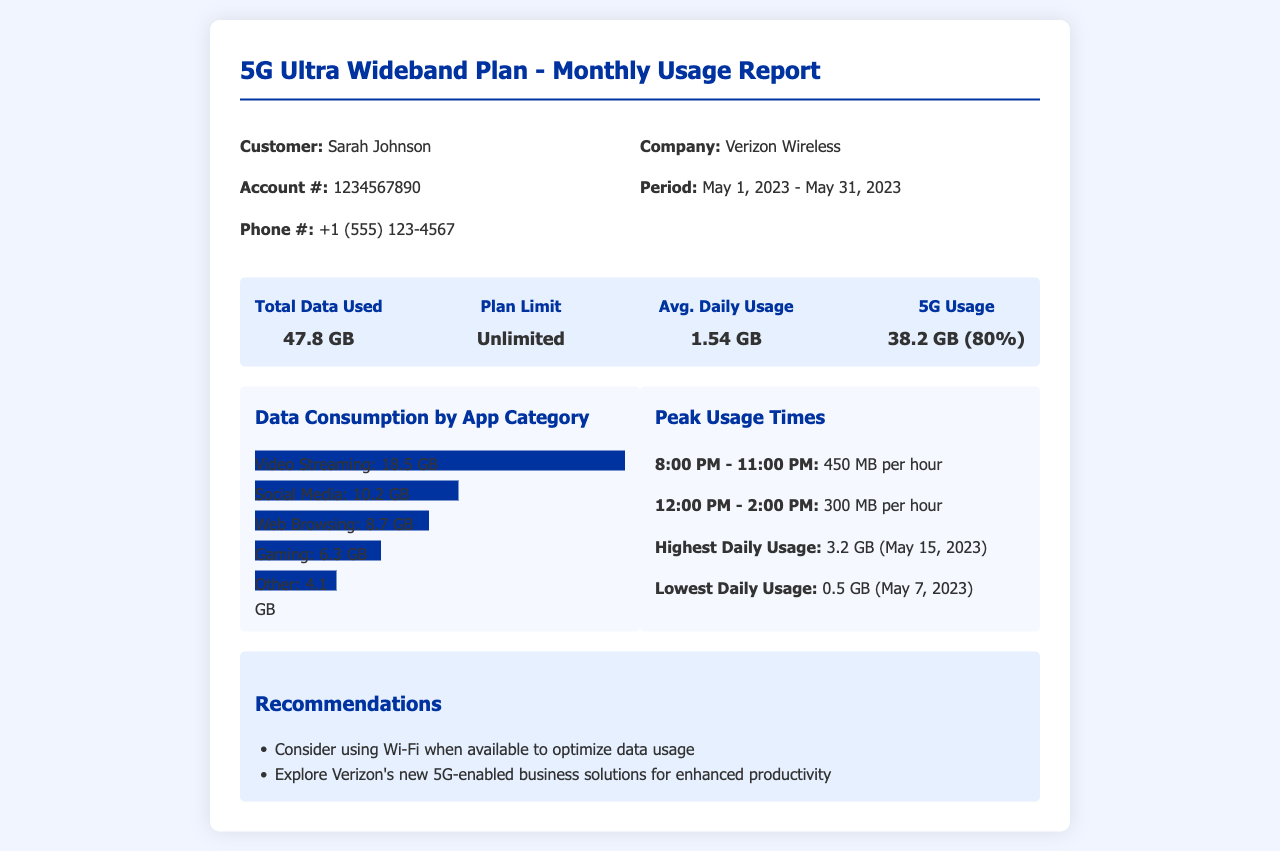What is the total data used? The total data used by the customer is prominently displayed in the report, which states "47.8 GB."
Answer: 47.8 GB What is the average daily usage? The document lists the average daily usage under the data summary section, which is "1.54 GB."
Answer: 1.54 GB What was the highest daily usage? The highest daily usage recorded in the report is mentioned as "3.2 GB" on a specific day.
Answer: 3.2 GB What percentage of usage was on 5G? The report states that 5G usage is "38.2 GB (80%)."
Answer: 80% What was the lowest daily usage? The document details the lowest daily usage, which is "0.5 GB" on a given day.
Answer: 0.5 GB What time was identified as a peak usage period? The document specifies that peak usage occurs during "8:00 PM - 11:00 PM."
Answer: 8:00 PM - 11:00 PM How much data was used for video streaming? The data consumption by app category shows that "Video Streaming: 18.5 GB."
Answer: 18.5 GB What is one recommendation given in the report? The report includes a recommendation to "Consider using Wi-Fi when available to optimize data usage."
Answer: Consider using Wi-Fi What is the account number mentioned in the report? The report includes the customer's account number, which is "1234567890."
Answer: 1234567890 